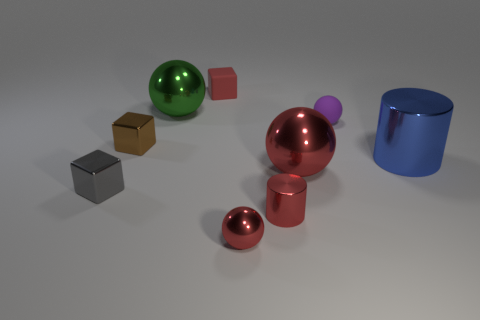Subtract all metallic spheres. How many spheres are left? 1 Add 1 large red things. How many objects exist? 10 Subtract 2 cylinders. How many cylinders are left? 0 Subtract all cylinders. How many objects are left? 7 Subtract all yellow cubes. How many purple cylinders are left? 0 Subtract all green objects. Subtract all red shiny things. How many objects are left? 5 Add 3 large red shiny objects. How many large red shiny objects are left? 4 Add 1 purple rubber blocks. How many purple rubber blocks exist? 1 Subtract all blue cylinders. How many cylinders are left? 1 Subtract 1 green spheres. How many objects are left? 8 